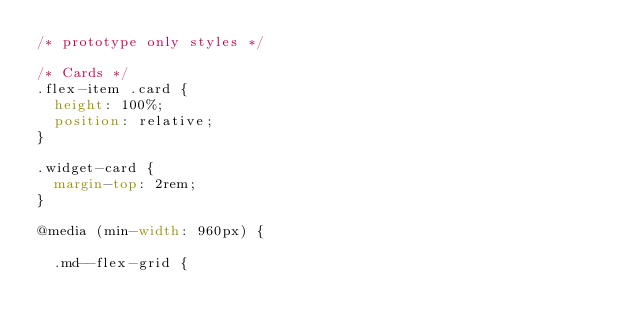<code> <loc_0><loc_0><loc_500><loc_500><_CSS_>/* prototype only styles */

/* Cards */
.flex-item .card {
  height: 100%;
  position: relative;
}

.widget-card {
  margin-top: 2rem;
}

@media (min-width: 960px) {

  .md--flex-grid {</code> 